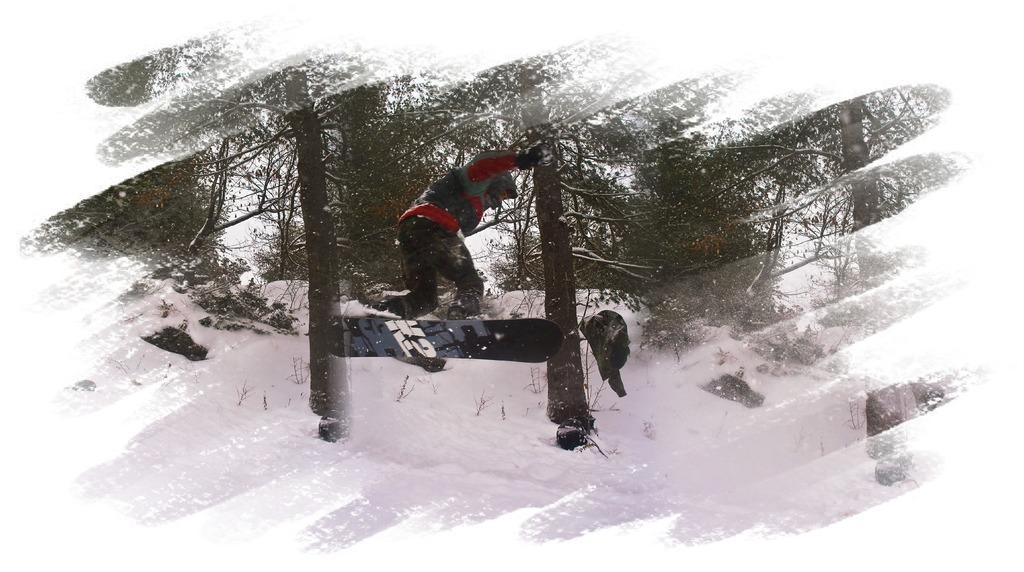What is the main subject of the image? There is a person in the image. What is the person doing in the image? The person is jumping with a snowboard. What type of surface is the person on? The person is on the snow. What can be seen in the background of the image? There are trees behind the person. Can you hear the person laughing while snowboarding in the image? The image is a still picture, so it does not capture any sounds, including laughter. 